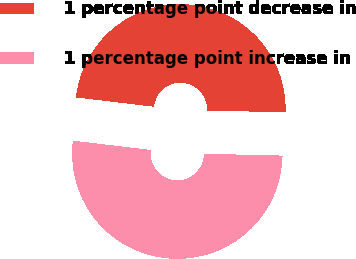Convert chart to OTSL. <chart><loc_0><loc_0><loc_500><loc_500><pie_chart><fcel>1 percentage point decrease in<fcel>1 percentage point increase in<nl><fcel>48.48%<fcel>51.52%<nl></chart> 